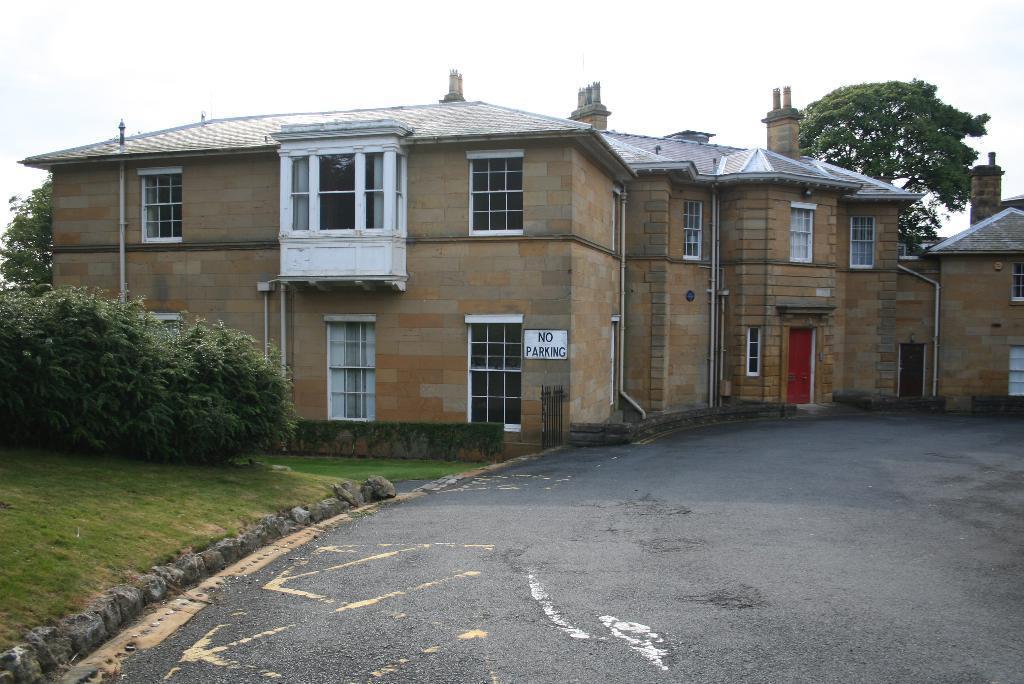Could you give a brief overview of what you see in this image? In this image we can see buildings, pipelines, windows, trees, sky with clouds, bushes, ground, stones and road. 